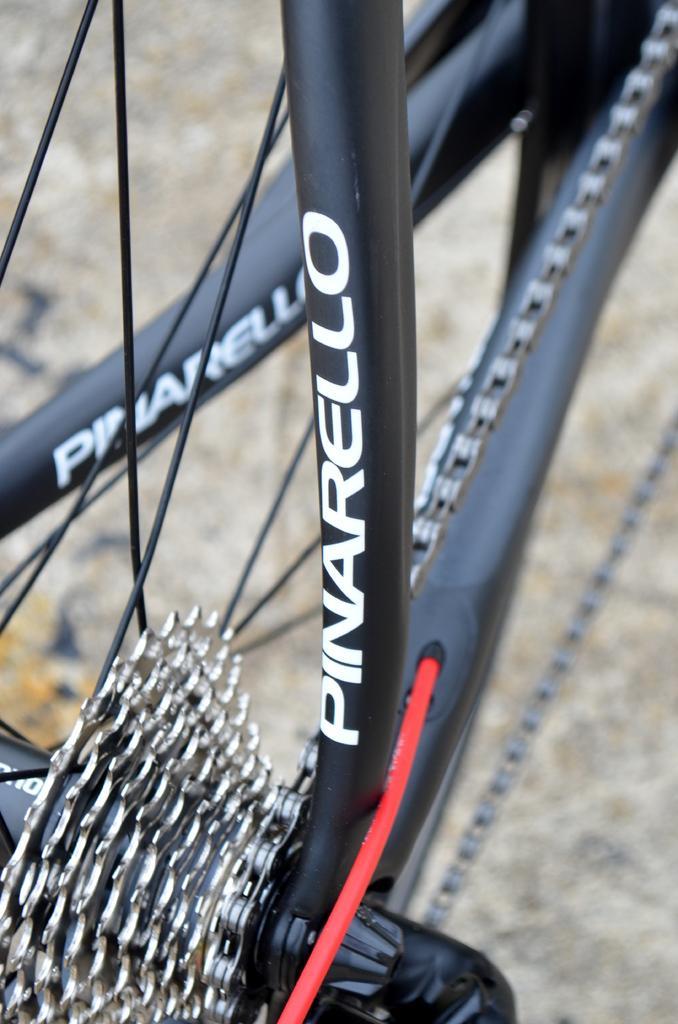Could you give a brief overview of what you see in this image? In this picture we can see black color bicycle frame and gears. Behind there is a ground. 